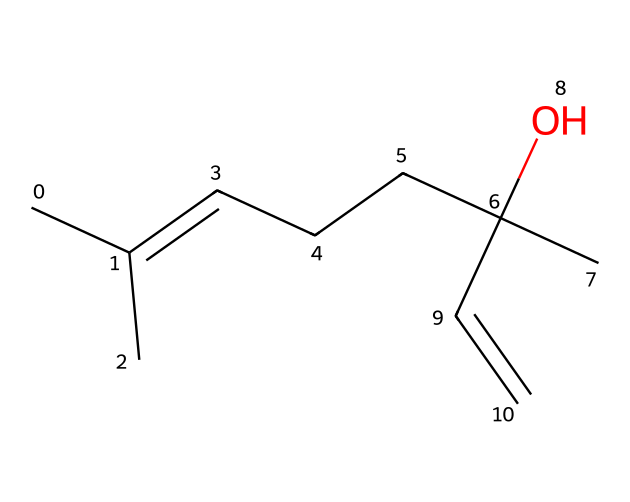What is the molecular formula of linalool? To find the molecular formula, identify the types and counts of each atom in the SMILES representation. The structure indicates there are 10 carbon atoms, 18 hydrogen atoms, and 1 oxygen atom, leading to the formula C10H18O.
Answer: C10H18O How many double bonds are present in linalool? Analyzing the SMILES, the 'C=C' notation indicates the presence of a double bond. Thus, there is 1 double bond in the structure.
Answer: 1 What functional group is present in linalool? The 'C(O)' in the structure indicates the presence of a hydroxyl group (–OH). This functional group is responsible for its alcohol classification.
Answer: hydroxyl Is linalool a linear or branched structure? Observing the branched connections in the SMILES representation, it is clear that linalool has a branched structure rather than a straight linear arrangement.
Answer: branched What type of compound is linalool? Based on its structure, where we see multiple carbon and hydrogen atoms and a functional group, linalool is classified as a terpene, which is a type of natural hydrocarbons primarily found in plants.
Answer: terpene How many chiral centers does linalool have? Examining the structure, we can identify one carbon atom that is attached to four different groups, indicating that this carbon is a chiral center. Thus, linalool has one chiral center.
Answer: 1 